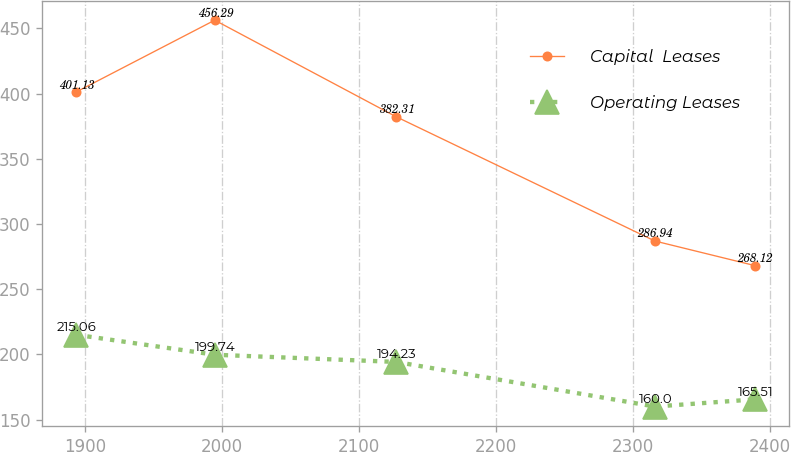<chart> <loc_0><loc_0><loc_500><loc_500><line_chart><ecel><fcel>Capital  Leases<fcel>Operating Leases<nl><fcel>1893.22<fcel>401.13<fcel>215.06<nl><fcel>1994.52<fcel>456.29<fcel>199.74<nl><fcel>2126.83<fcel>382.31<fcel>194.23<nl><fcel>2315.76<fcel>286.94<fcel>160<nl><fcel>2388.65<fcel>268.12<fcel>165.51<nl></chart> 